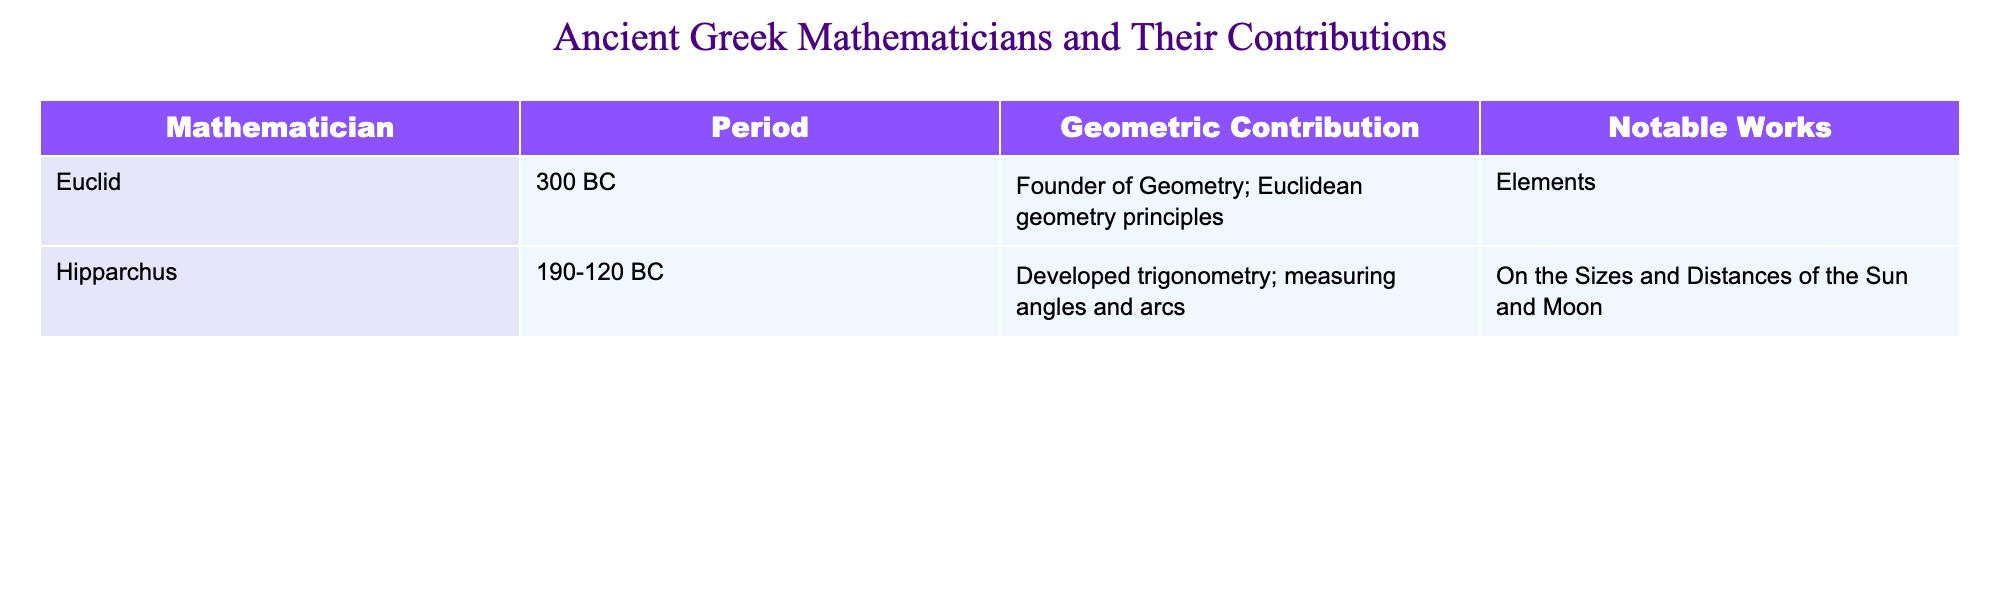What contribution did Euclid make to geometry? According to the table, Euclid's contribution is listed as "Founder of Geometry; Euclidean geometry principles." Therefore, he is known for establishing foundational principles of geometry.
Answer: Founder of Geometry; Euclidean geometry principles Which period did Hipparchus belong to? The table specifies that Hipparchus was active during the period of 190-120 BC. This information is directly taken from the "Period" column next to his name.
Answer: 190-120 BC Is it true that both mathematicians contributed to geometry? Reviewing the table, it shows that both Euclid and Hipparchus are listed with contributions specifically to geometry. Therefore, the statement is true.
Answer: Yes Which notable work is attributed to Euclid? The table indicates that the notable work attributed to Euclid is "Elements." This can be directly found in the "Notable Works" column next to his name.
Answer: Elements What is the relationship between Euclid's period and Hipparchus's period? Euclid is described as belonging to a period of 300 BC, while Hipparchus is from 190-120 BC. Notably, Euclid's period predates that of Hipparchus by more than a century.
Answer: Euclid's period is earlier than Hipparchus's What are the contributions of Hipparchus? According to the table, Hipparchus developed trigonometry and worked on measuring angles and arcs. This information can be found in the respective columns for "Geometric Contribution."
Answer: Developed trigonometry; measuring angles and arcs Which mathematician's contributions are more foundational? By analyzing the contributions in the table, Euclid's contribution as the "Founder of Geometry" can be seen as more foundational than Hipparchus's contributions in trigonometry, which are built upon existing geometric principles.
Answer: Euclid's contributions are more foundational What is the total number of notable works mentioned in the table? The table lists notable works as "Elements" for Euclid and "On the Sizes and Distances of the Sun and Moon" for Hipparchus. Thus, there are 2 notable works combined from both mathematicians.
Answer: 2 Was Hipparchus known for geometry alone? The contribution column indicates that while Hipparchus made significant contributions to geometry through trigonometry, he is primarily recognized for his developments related to angles and arcs specifically. Hence, he was not known solely for geometry.
Answer: No 